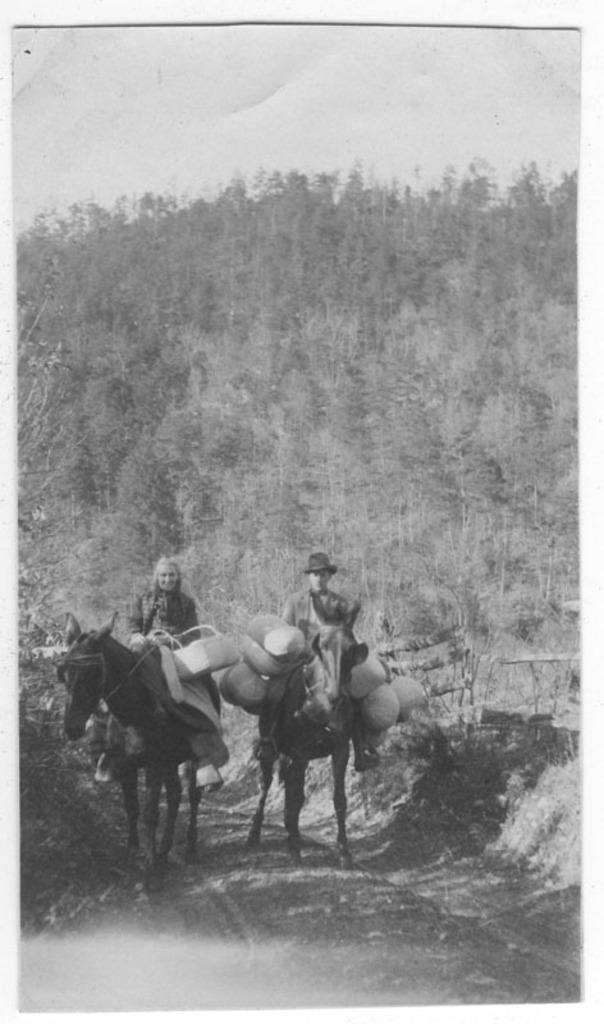Can you describe this image briefly? They are two members riding horses with some luggage. On the horse, one is a man and the other is a woman. In the background we can observe some trees here and a sky. 